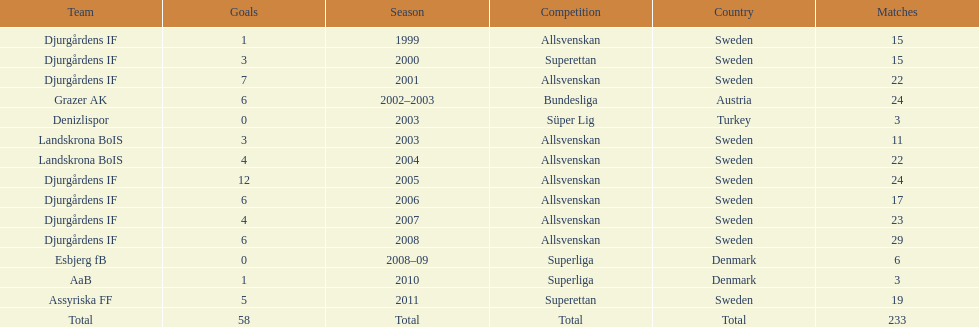What country is team djurgårdens if not from? Sweden. 